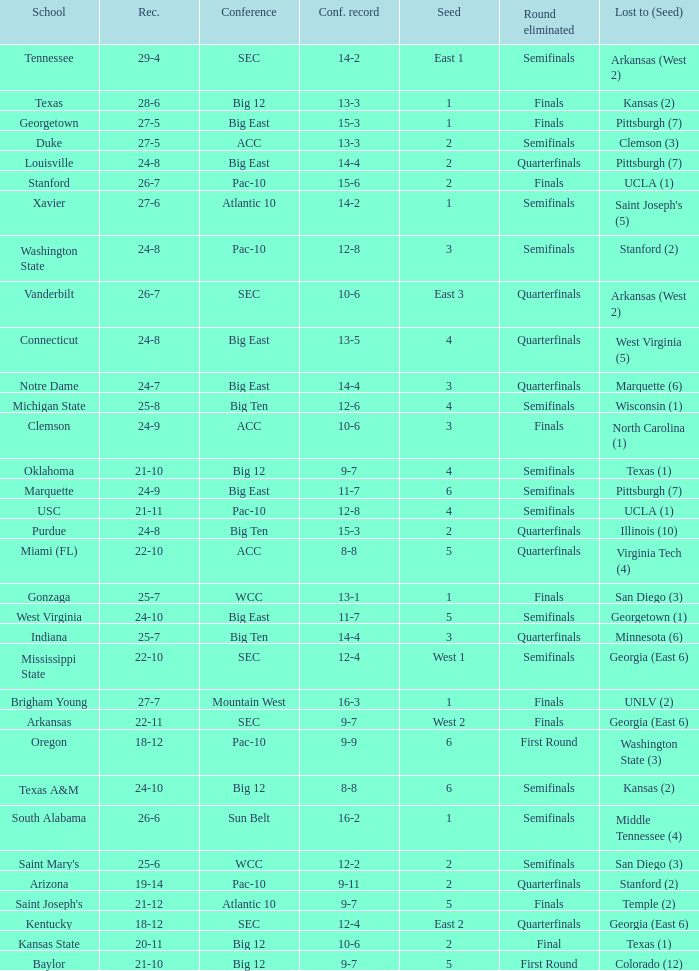Name the round eliminated where conference record is 12-6 Semifinals. 